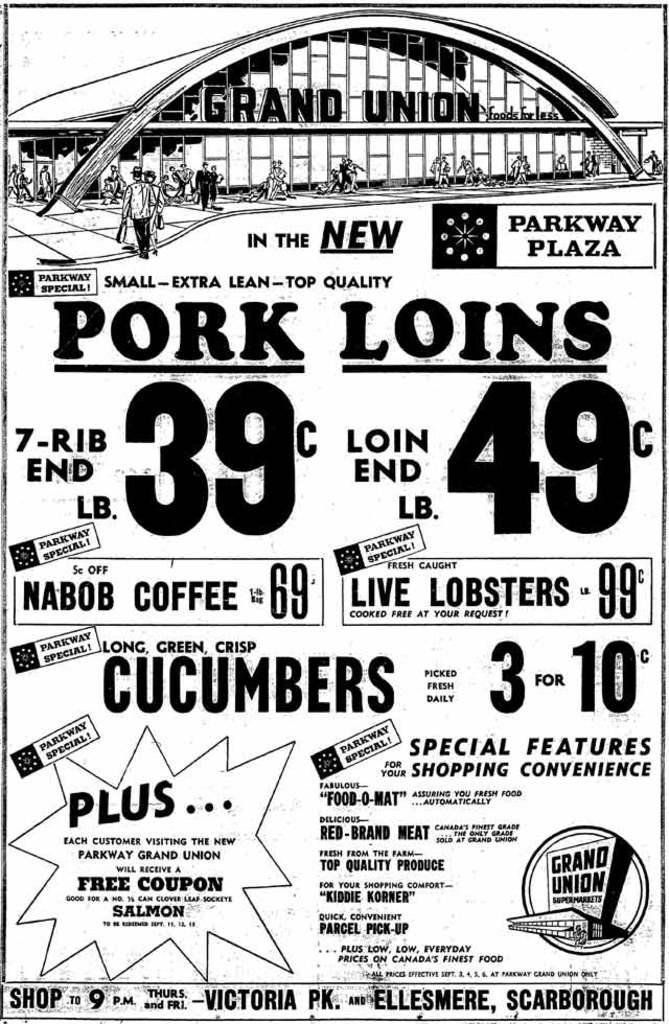How would you summarize this image in a sentence or two? This is a black and white poster. There are texts and numbers written on it. At the top we can see few person are standing on the ground and a building. 